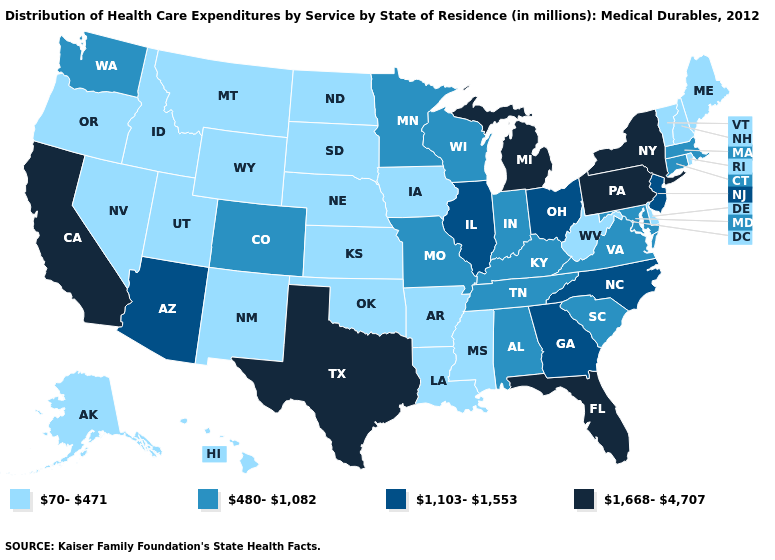Name the states that have a value in the range 1,103-1,553?
Short answer required. Arizona, Georgia, Illinois, New Jersey, North Carolina, Ohio. What is the highest value in states that border Minnesota?
Be succinct. 480-1,082. Does the first symbol in the legend represent the smallest category?
Write a very short answer. Yes. What is the value of Virginia?
Short answer required. 480-1,082. What is the value of Tennessee?
Answer briefly. 480-1,082. What is the value of Maine?
Short answer required. 70-471. Does North Dakota have the highest value in the USA?
Short answer required. No. Name the states that have a value in the range 1,103-1,553?
Answer briefly. Arizona, Georgia, Illinois, New Jersey, North Carolina, Ohio. Does Oklahoma have the same value as Vermont?
Give a very brief answer. Yes. Does Massachusetts have a lower value than Maine?
Keep it brief. No. Which states have the lowest value in the USA?
Concise answer only. Alaska, Arkansas, Delaware, Hawaii, Idaho, Iowa, Kansas, Louisiana, Maine, Mississippi, Montana, Nebraska, Nevada, New Hampshire, New Mexico, North Dakota, Oklahoma, Oregon, Rhode Island, South Dakota, Utah, Vermont, West Virginia, Wyoming. Name the states that have a value in the range 1,668-4,707?
Concise answer only. California, Florida, Michigan, New York, Pennsylvania, Texas. Which states have the lowest value in the South?
Write a very short answer. Arkansas, Delaware, Louisiana, Mississippi, Oklahoma, West Virginia. Among the states that border South Carolina , which have the highest value?
Give a very brief answer. Georgia, North Carolina. What is the value of Illinois?
Short answer required. 1,103-1,553. 